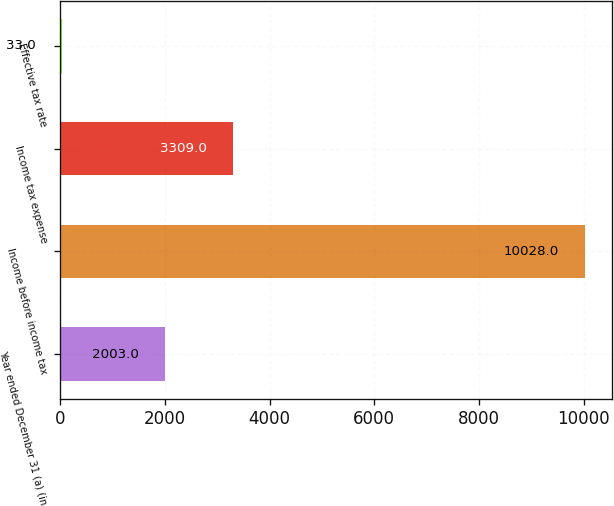Convert chart. <chart><loc_0><loc_0><loc_500><loc_500><bar_chart><fcel>Year ended December 31 (a) (in<fcel>Income before income tax<fcel>Income tax expense<fcel>Effective tax rate<nl><fcel>2003<fcel>10028<fcel>3309<fcel>33<nl></chart> 